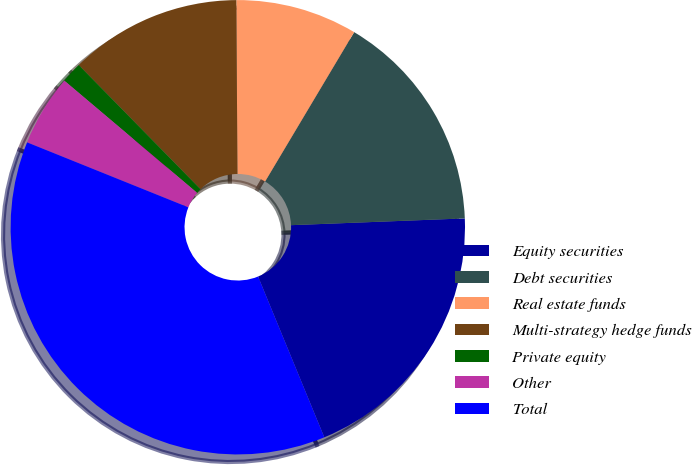<chart> <loc_0><loc_0><loc_500><loc_500><pie_chart><fcel>Equity securities<fcel>Debt securities<fcel>Real estate funds<fcel>Multi-strategy hedge funds<fcel>Private equity<fcel>Other<fcel>Total<nl><fcel>19.4%<fcel>15.82%<fcel>8.66%<fcel>12.24%<fcel>1.49%<fcel>5.07%<fcel>37.31%<nl></chart> 